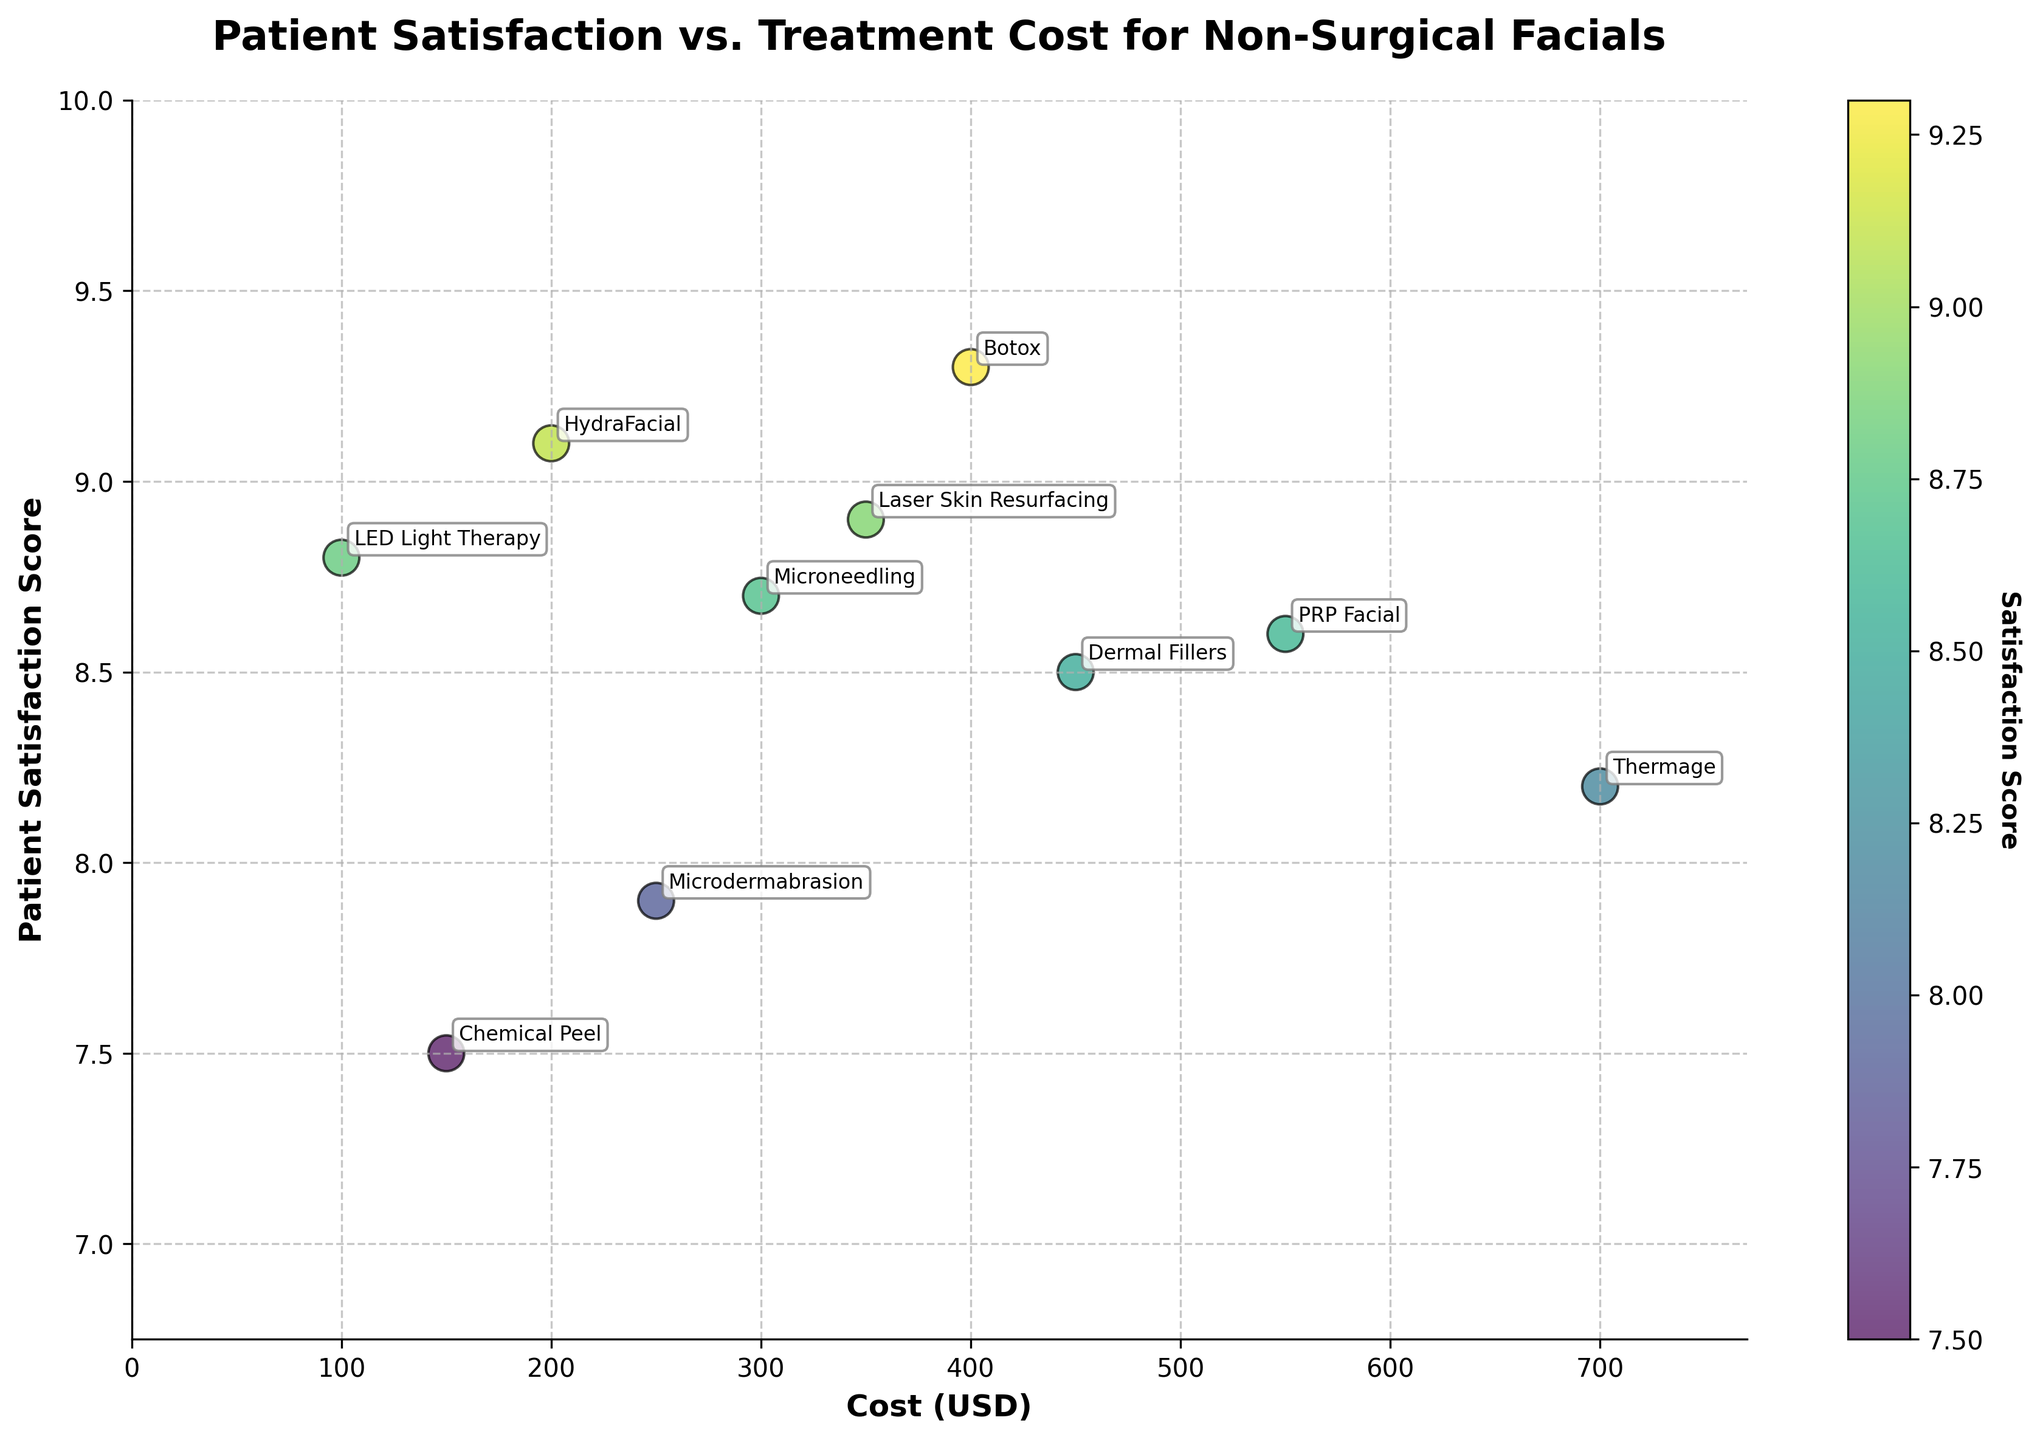What is the cost range for the treatments shown in the graph? The x-axis represents the treatment cost in USD, ranging from 0 to approximately 770 USD.
Answer: 0 to 770 USD Which treatment has the highest patient satisfaction score? Identify the data point with the highest y-value on the scatter plot. It's labeled 'Botox' with a score of 9.3.
Answer: Botox What is the relationship between the cost of HydraFacial and LED Light Therapy? Compare the x-coordinates of the data points labeled 'HydraFacial' and 'LED Light Therapy'. HydraFacial is 200 USD, and LED Light Therapy is 100 USD.
Answer: HydraFacial costs more than LED Light Therapy Which treatment has the lowest cost? Identify the treatment at the far left on the x-axis. It's labeled 'LED Light Therapy' with a cost of 100 USD.
Answer: LED Light Therapy How does the patient satisfaction score of Chemical Peel compare to that of Laser Skin Resurfacing? Compare the y-coordinates of Chemical Peel (7.5) and Laser Skin Resurfacing (8.9).
Answer: Laser Skin Resurfacing has a higher score What is the average cost of treatments with a patient satisfaction score above 8.5? Identify treatments with scores above 8.5: Microneedling, HydraFacial, Laser Skin Resurfacing, Botox, LED Light Therapy, PRP Facial. Calculate their average cost: (300+200+350+400+100+550)/6 = 316.7
Answer: 316.7 USD What is the distribution of colors in the scatter plot, and what do they represent? The scatter plot uses a color gradient from light to dark, representing increasing patient satisfaction scores, indicated by the color bar. The darker the dot, the higher the score.
Answer: Color gradient from light (lower scores) to dark (higher scores) Which treatment costs the most and what is its satisfaction score? Identify the treatment at the far right on the x-axis. It's labeled 'Thermage' with a cost of 700 USD and a satisfaction score of 8.2.
Answer: Thermage, score 8.2 Is there a general trend between treatment cost and patient satisfaction score? Observe the scatter plot as a whole. Although there's some variability, higher-cost treatments tend to have higher satisfaction scores, but the trend isn't very strong.
Answer: Weak positive correlation What is the title of the scatter plot? Locate the text at the top of the figure. It is 'Patient Satisfaction vs. Treatment Cost for Non-Surgical Facials'.
Answer: Patient Satisfaction vs. Treatment Cost for Non-Surgical Facials 